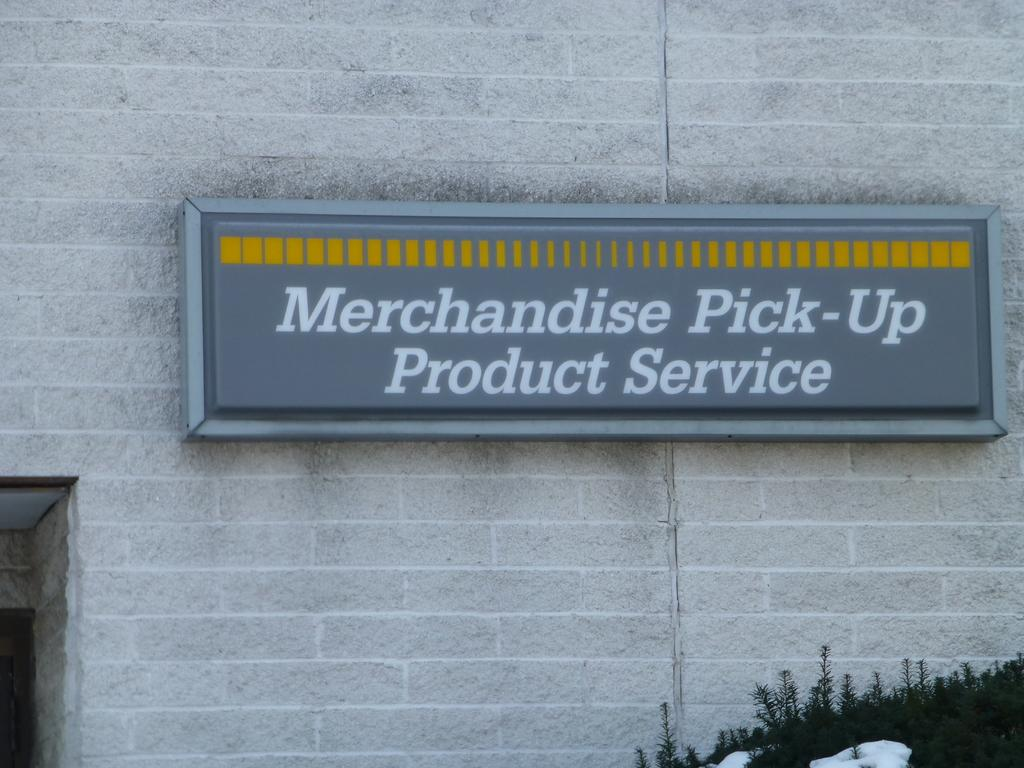What is on the wall in the image? There is a name board on the wall in the image. What else can be seen in the image besides the name board? There are plants visible in the image. How many stars can be seen on the bed in the image? There is no bed present in the image, so it is not possible to determine the number of stars on it. 